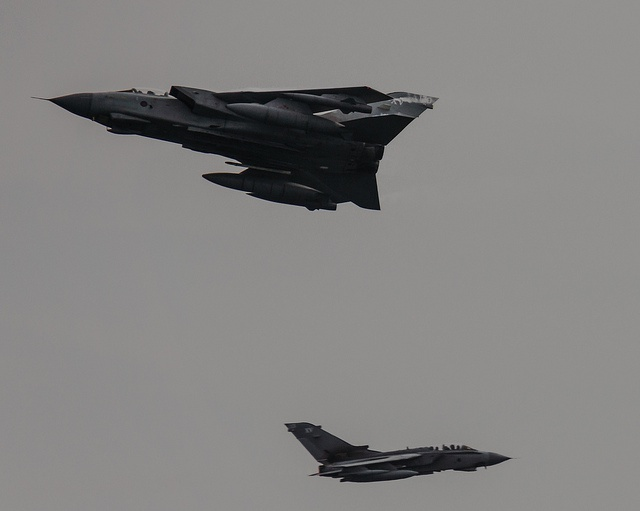Describe the objects in this image and their specific colors. I can see airplane in gray and black tones and airplane in gray and black tones in this image. 